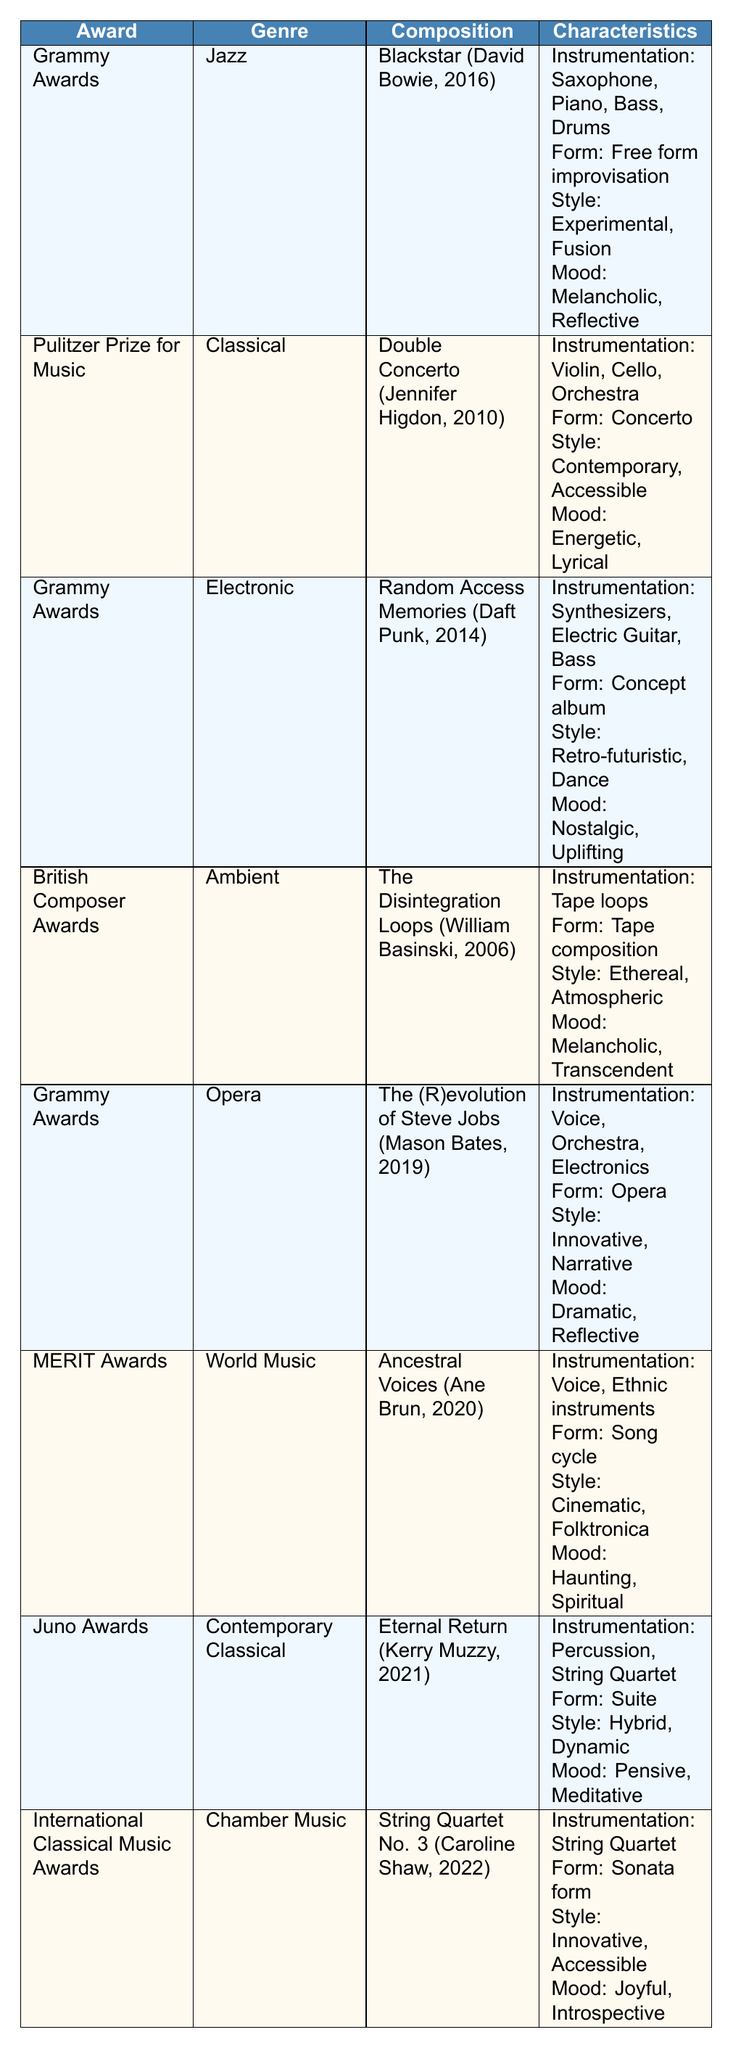What genre does the composition "Eternal Return" belong to? The table indicates that "Eternal Return," composed by Kerry Muzzy, is categorized under the genre "Contemporary Classical." This is directly referenced in the row corresponding to the Juno Awards.
Answer: Contemporary Classical Which award was given for the composition "Blackstar"? The table shows that "Blackstar," composed by David Bowie, received the Grammy Award in 2016. This is found in the row corresponding to the Grammy Awards.
Answer: Grammy Awards How many compositions listed were awarded the Grammy Awards? There are four compositions in the table that are listed under the Grammy Awards: "Blackstar," "Random Access Memories," "The (R)evolution of Steve Jobs," and "Eternal Return." Counting these entries gives a total of four.
Answer: 4 Did "Ancestral Voices" win an award? According to the table, "Ancestral Voices," composed by Ane Brun, was awarded the MERIT Awards. Therefore, it is true that this composition won an award.
Answer: Yes Which composition has a melancholic mood in the characteristics? Upon reviewing the characteristics listed in the table, both "Blackstar" and "The Disintegration Loops" express a melancholic mood. They can be identified from their respective rows.
Answer: "Blackstar" and "The Disintegration Loops" What is the average year of award for compositions in the Electronic genre? The table shows one entry for the Electronic genre, which is "Random Access Memories," awarded in 2014. Since there's only one entry, the average year is just 2014. There are no other entries to include in the average calculation.
Answer: 2014 Which composer won the Pulitzer Prize for Music and what was the composition title? The table specifies that Jennifer Higdon won the Pulitzer Prize for Music for her composition titled "Double Concerto," which can be found in the relevant row.
Answer: Jennifer Higdon, Double Concerto Which composition features the instrumentation including "Tape loops"? According to the table, "The Disintegration Loops," composed by William Basinski, includes "Tape loops" as part of its instrumentation. This can be directly identified in the corresponding row.
Answer: The Disintegration Loops What are the characteristics of the composition "The (R)evolution of Steve Jobs"? The table lists the characteristics of "The (R)evolution of Steve Jobs" as follows: Instrumentation: Voice, Orchestra, Electronics; Form: Opera; Style: Innovative, Narrative; Mood: Dramatic, Reflective. This summary is structured in the same row of the table.
Answer: Voice, Orchestra, Electronics; Opera; Innovative, Narrative; Dramatic, Reflective 